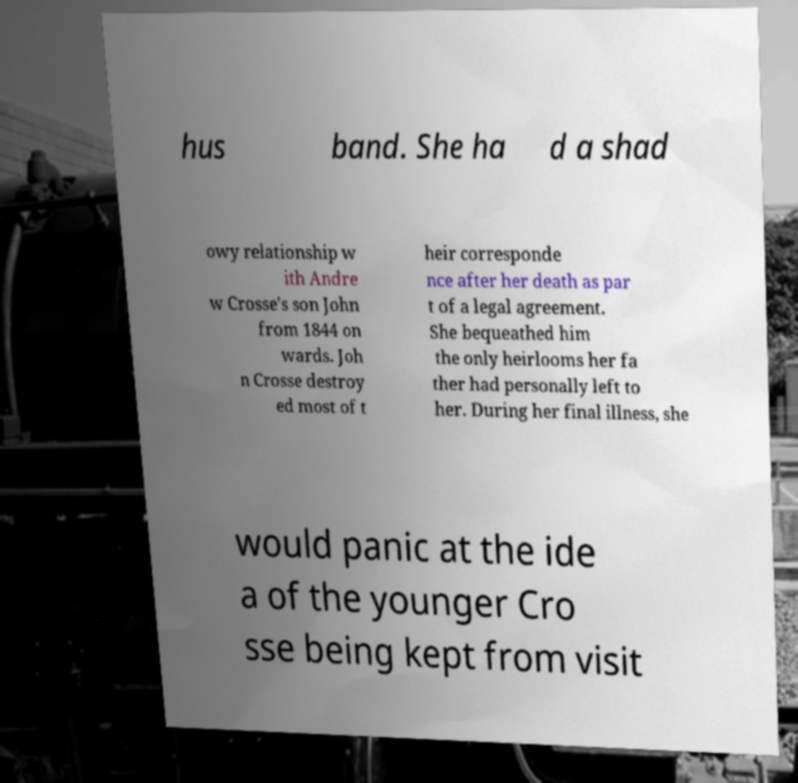Can you read and provide the text displayed in the image?This photo seems to have some interesting text. Can you extract and type it out for me? hus band. She ha d a shad owy relationship w ith Andre w Crosse's son John from 1844 on wards. Joh n Crosse destroy ed most of t heir corresponde nce after her death as par t of a legal agreement. She bequeathed him the only heirlooms her fa ther had personally left to her. During her final illness, she would panic at the ide a of the younger Cro sse being kept from visit 